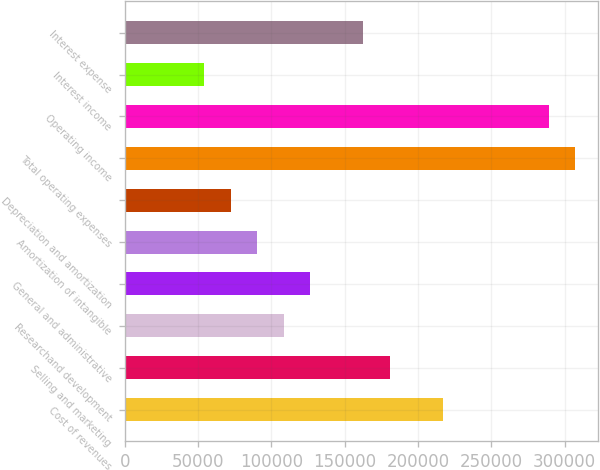<chart> <loc_0><loc_0><loc_500><loc_500><bar_chart><fcel>Cost of revenues<fcel>Selling and marketing<fcel>Researchand development<fcel>General and administrative<fcel>Amortization of intangible<fcel>Depreciation and amortization<fcel>Total operating expenses<fcel>Operating income<fcel>Interest income<fcel>Interest expense<nl><fcel>216989<fcel>180824<fcel>108495<fcel>126577<fcel>90412.4<fcel>72330<fcel>307400<fcel>289318<fcel>54247.7<fcel>162742<nl></chart> 